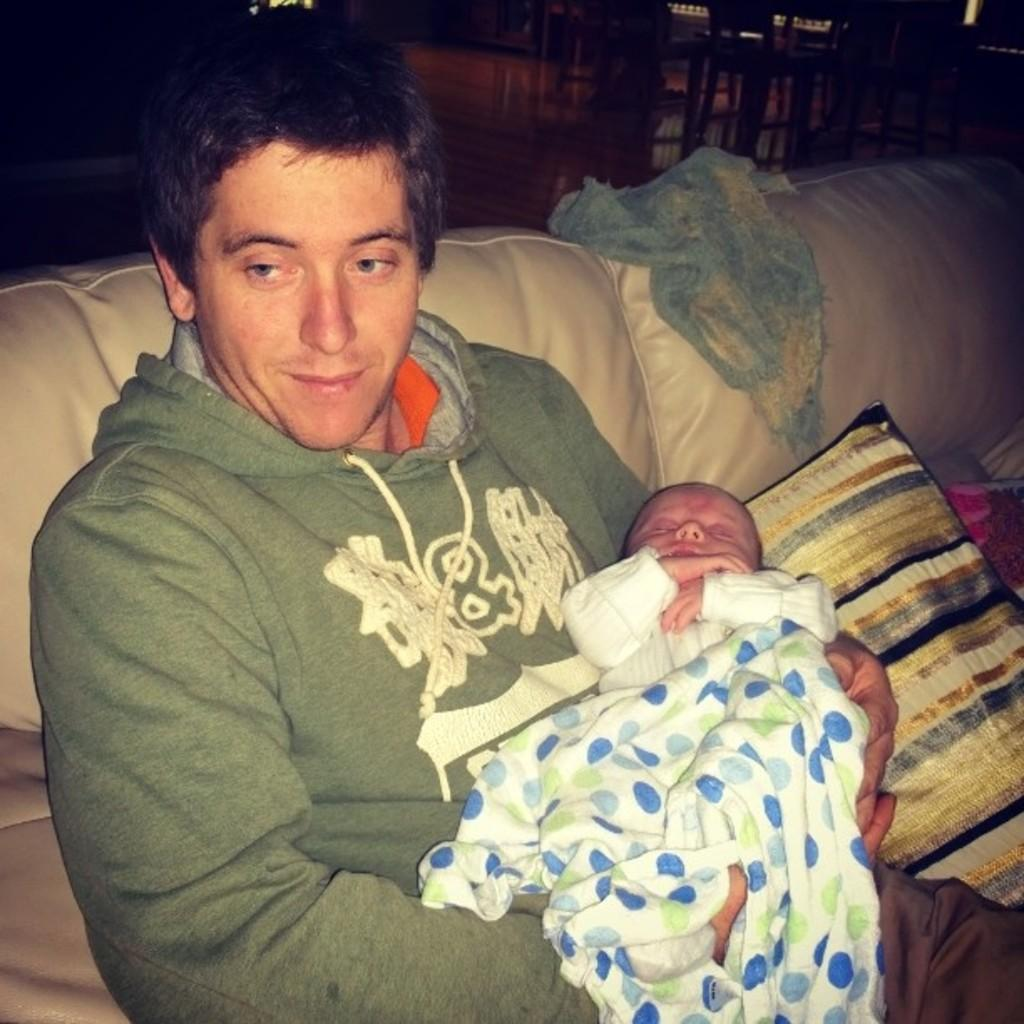Who is present in the image? There is a man in the image. What is the man doing in the image? The man is sitting on a sofa and smiling. Is there anyone else in the image besides the man? Yes, there is a baby on the man. What can be seen in the background of the image? There are chairs in the background of the image. What type of pen is the man holding in the image? There is no pen present in the image; the man is holding a baby. Can you hear the man's voice in the image? The image is a still photograph, so it does not capture sound, including the man's voice. 